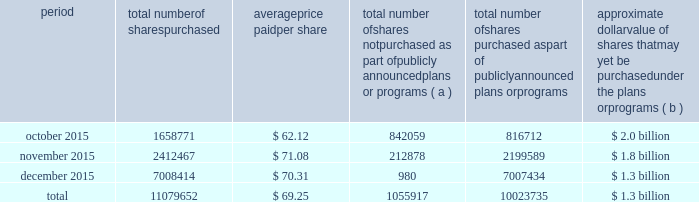Table of contents the table discloses purchases of shares of our common stock made by us or on our behalf during the fourth quarter of 2015 .
Period total number of shares purchased average price paid per share total number of shares not purchased as part of publicly announced plans or programs ( a ) total number of shares purchased as part of publicly announced plans or programs approximate dollar value of shares that may yet be purchased under the plans or programs ( b ) .
( a ) the shares reported in this column represent purchases settled in the fourth quarter of 2015 relating to ( i ) our purchases of shares in open-market transactions to meet our obligations under stock-based compensation plans , and ( ii ) our purchases of shares from our employees and non-employee directors in connection with the exercise of stock options , the vesting of restricted stock , and other stock compensation transactions in accordance with the terms of our stock-based compensation plans .
( b ) on july 13 , 2015 , we announced that our board of directors approved our purchase of $ 2.5 billion of our outstanding common stock ( with no expiration date ) , which was in addition to the remaining amount available under our $ 3 billion program previously authorized .
During the third quarter of 2015 , we completed our purchases under the $ 3 billion program .
As of december 31 , 2015 , we had $ 1.3 billion remaining available for purchase under the $ 2.5 billion program. .
As of december 31 , 2015 , what was the percent of the $ 2.5 billion program remaining available for purchase? 
Computations: (1.3 / 2.5)
Answer: 0.52. 